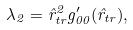<formula> <loc_0><loc_0><loc_500><loc_500>\lambda _ { 2 } = \hat { r } _ { t r } ^ { 2 } g _ { 0 0 } ^ { \prime } ( \hat { r } _ { t r } ) ,</formula> 